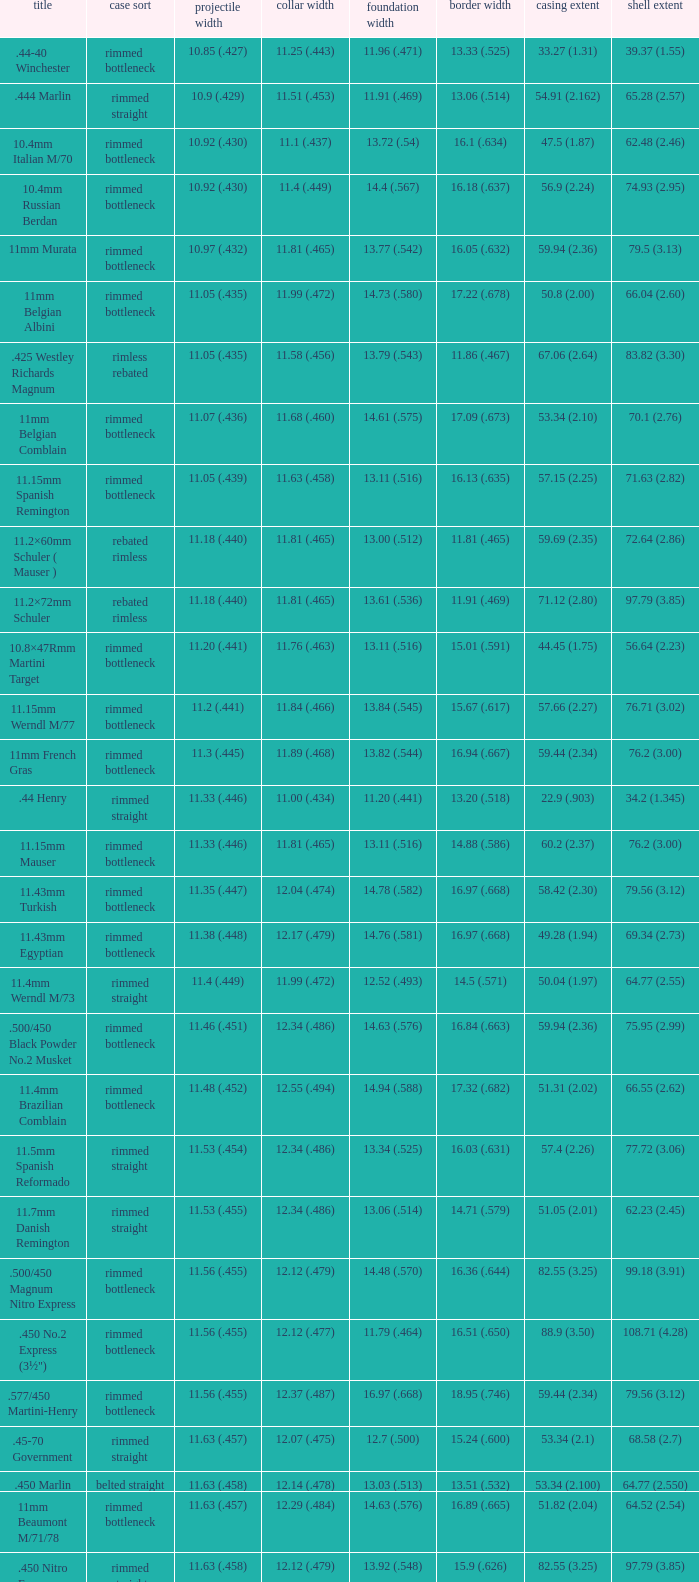Which Bullet diameter has a Name of 11.4mm werndl m/73? 11.4 (.449). 